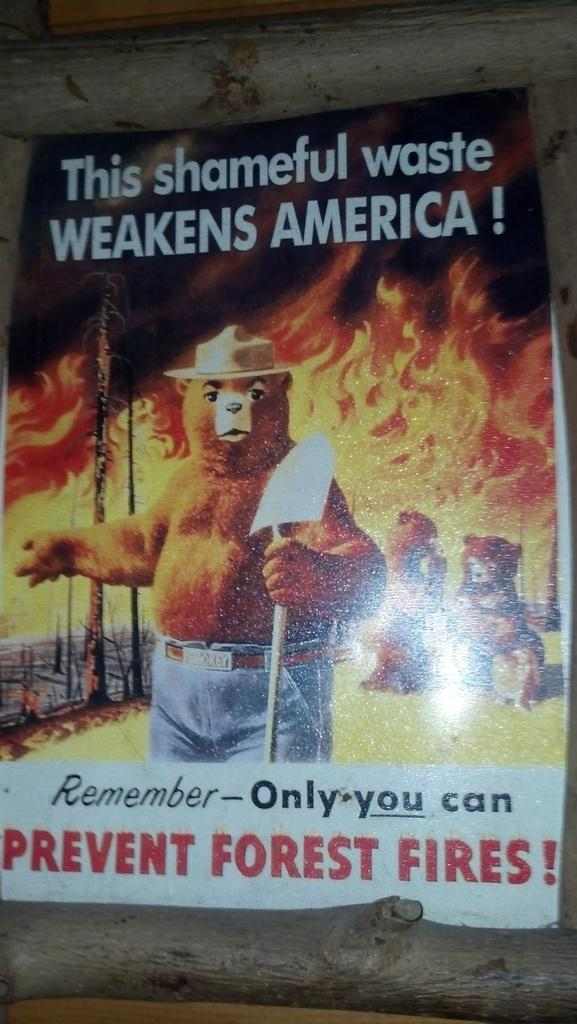What is the main subject in the center of the image? There is a poster in the center of the image. How is the poster attached to the wall? The poster is stuck to the wall. What can be read on the poster? There is text written on the poster. What type of illustrations are featured on the poster? There are toys depicted on the poster. What type of station is shown in the image? There is no station depicted in the image; it features a poster with text and illustrations of toys. What operation is being performed in the image? There is no operation being performed in the image; it is a static image of a poster. 